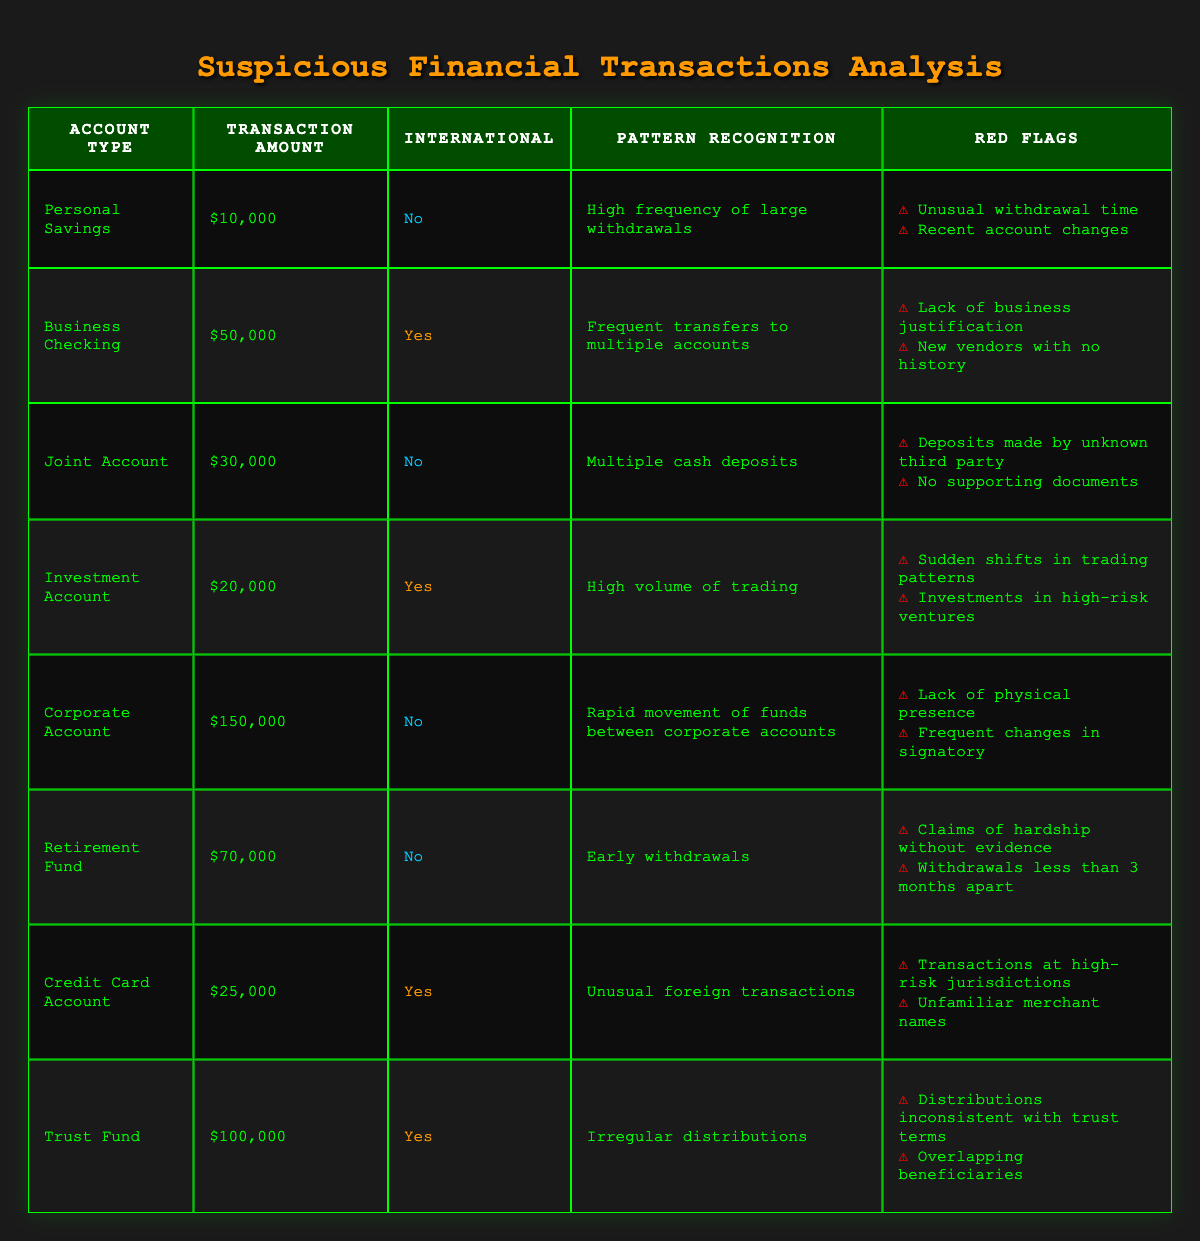What is the total transaction amount for international accounts? There are three international accounts: Business Checking ($50,000), Investment Account ($20,000), Credit Card Account ($25,000), and Trust Fund ($100,000). We can sum them up: 50,000 + 20,000 + 25,000 + 100,000 = 195,000.
Answer: 195,000 What are the red flags associated with the Retirement Fund account? By inspecting the Retirement Fund row, we find that it has two red flags: Claims of hardship without evidence, and Withdrawals less than 3 months apart.
Answer: Claims of hardship without evidence; Withdrawals less than 3 months apart Do any accounts have transactions made by unknown third parties? The Joint Account has a red flag indicating deposits made by unknown third parties. Therefore, the answer is yes.
Answer: Yes Which account type has the highest individual transaction amount? By reviewing the transaction amounts, the Corporate Account has the highest amount at $150,000, which is the largest value seen in any row.
Answer: Corporate Account What is the average transaction amount across all accounts? We calculate the average transaction amount by first summing all transaction amounts: 10,000 + 50,000 + 30,000 + 20,000 + 150,000 + 70,000 + 25,000 + 100,000 = 455,000. There are 8 accounts, so the average is 455,000 / 8 = 56,875.
Answer: 56,875 How many accounts show a pattern of high volume or frequency in their transactions? The accounts that show high volume patterns are Business Checking (Frequent transfers to multiple accounts), Investment Account (High volume of trading), Corporate Account (Rapid movement of funds), and Trust Fund (Irregular distributions). This totals 4 accounts.
Answer: 4 Is there a pattern recognition noted in the Personal Savings account? Yes, the Personal Savings account indicates a high frequency of large withdrawals as its pattern recognition. Therefore, the answer is yes.
Answer: Yes What are the red flags for the Business Checking account? Looking at the Business Checking entry, the red flags listed are Lack of business justification, and New vendors with no history.
Answer: Lack of business justification; New vendors with no history Which accounts are classified as domestic transactions? By reviewing the accounts, the Personal Savings, Joint Account, Corporate Account, and Retirement Fund are classified as domestic transactions. This gives us a total of 4 domestic accounts.
Answer: 4 